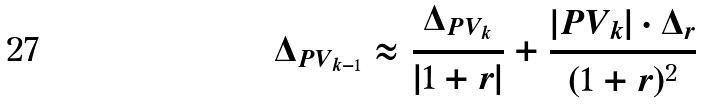<formula> <loc_0><loc_0><loc_500><loc_500>\Delta _ { P V _ { k - 1 } } \approx \frac { \Delta _ { P V _ { k } } } { | 1 + r | } + \frac { | P V _ { k } | \cdot \Delta _ { r } } { ( 1 + r ) ^ { 2 } }</formula> 